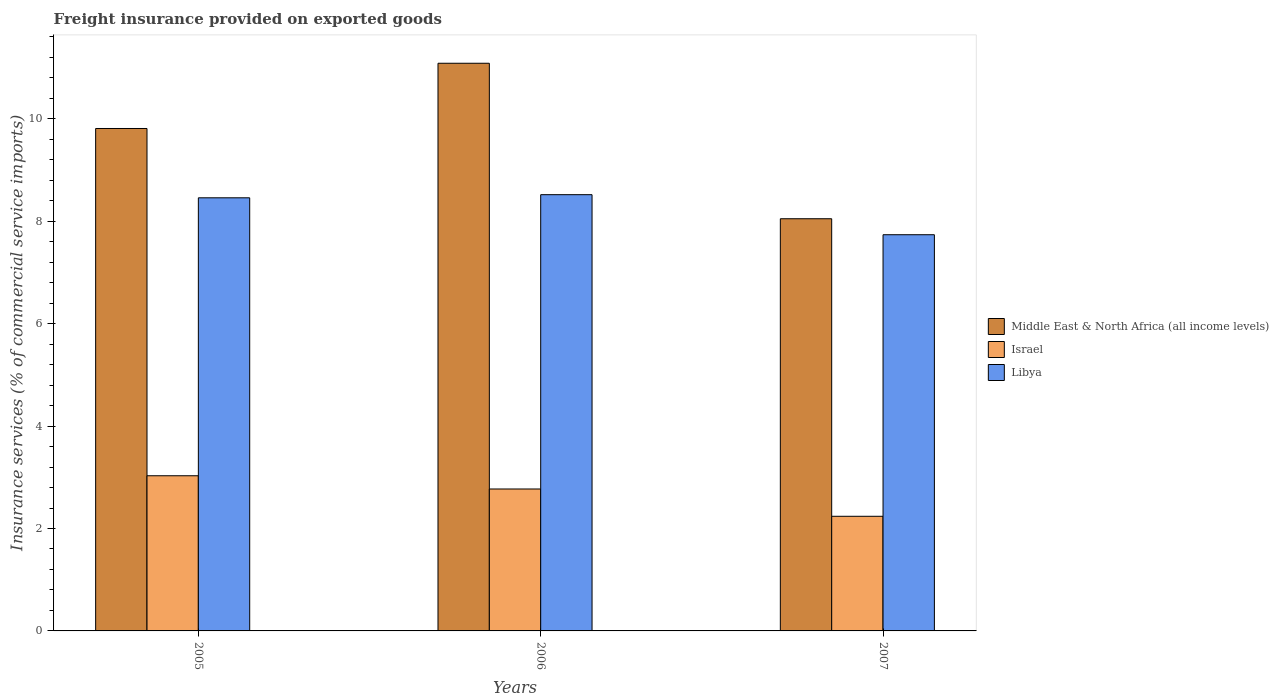How many different coloured bars are there?
Ensure brevity in your answer.  3. Are the number of bars per tick equal to the number of legend labels?
Offer a terse response. Yes. How many bars are there on the 1st tick from the left?
Provide a short and direct response. 3. What is the label of the 1st group of bars from the left?
Keep it short and to the point. 2005. What is the freight insurance provided on exported goods in Middle East & North Africa (all income levels) in 2006?
Your response must be concise. 11.09. Across all years, what is the maximum freight insurance provided on exported goods in Libya?
Offer a very short reply. 8.52. Across all years, what is the minimum freight insurance provided on exported goods in Israel?
Your answer should be compact. 2.24. In which year was the freight insurance provided on exported goods in Israel minimum?
Give a very brief answer. 2007. What is the total freight insurance provided on exported goods in Libya in the graph?
Your answer should be compact. 24.72. What is the difference between the freight insurance provided on exported goods in Libya in 2006 and that in 2007?
Provide a succinct answer. 0.78. What is the difference between the freight insurance provided on exported goods in Israel in 2005 and the freight insurance provided on exported goods in Middle East & North Africa (all income levels) in 2006?
Your response must be concise. -8.06. What is the average freight insurance provided on exported goods in Israel per year?
Your answer should be very brief. 2.68. In the year 2007, what is the difference between the freight insurance provided on exported goods in Libya and freight insurance provided on exported goods in Israel?
Make the answer very short. 5.5. What is the ratio of the freight insurance provided on exported goods in Libya in 2006 to that in 2007?
Provide a short and direct response. 1.1. Is the freight insurance provided on exported goods in Israel in 2006 less than that in 2007?
Keep it short and to the point. No. What is the difference between the highest and the second highest freight insurance provided on exported goods in Middle East & North Africa (all income levels)?
Your response must be concise. 1.27. What is the difference between the highest and the lowest freight insurance provided on exported goods in Middle East & North Africa (all income levels)?
Your answer should be compact. 3.04. In how many years, is the freight insurance provided on exported goods in Middle East & North Africa (all income levels) greater than the average freight insurance provided on exported goods in Middle East & North Africa (all income levels) taken over all years?
Your answer should be compact. 2. Is the sum of the freight insurance provided on exported goods in Libya in 2006 and 2007 greater than the maximum freight insurance provided on exported goods in Middle East & North Africa (all income levels) across all years?
Keep it short and to the point. Yes. What does the 2nd bar from the left in 2005 represents?
Provide a succinct answer. Israel. What does the 3rd bar from the right in 2007 represents?
Your response must be concise. Middle East & North Africa (all income levels). Is it the case that in every year, the sum of the freight insurance provided on exported goods in Libya and freight insurance provided on exported goods in Israel is greater than the freight insurance provided on exported goods in Middle East & North Africa (all income levels)?
Keep it short and to the point. Yes. How many bars are there?
Your answer should be compact. 9. Are all the bars in the graph horizontal?
Give a very brief answer. No. Does the graph contain any zero values?
Provide a short and direct response. No. Does the graph contain grids?
Make the answer very short. No. Where does the legend appear in the graph?
Your answer should be very brief. Center right. How many legend labels are there?
Keep it short and to the point. 3. What is the title of the graph?
Provide a succinct answer. Freight insurance provided on exported goods. Does "Cote d'Ivoire" appear as one of the legend labels in the graph?
Provide a short and direct response. No. What is the label or title of the Y-axis?
Offer a very short reply. Insurance services (% of commercial service imports). What is the Insurance services (% of commercial service imports) of Middle East & North Africa (all income levels) in 2005?
Offer a terse response. 9.81. What is the Insurance services (% of commercial service imports) in Israel in 2005?
Ensure brevity in your answer.  3.03. What is the Insurance services (% of commercial service imports) of Libya in 2005?
Provide a short and direct response. 8.46. What is the Insurance services (% of commercial service imports) in Middle East & North Africa (all income levels) in 2006?
Give a very brief answer. 11.09. What is the Insurance services (% of commercial service imports) of Israel in 2006?
Ensure brevity in your answer.  2.77. What is the Insurance services (% of commercial service imports) of Libya in 2006?
Offer a terse response. 8.52. What is the Insurance services (% of commercial service imports) of Middle East & North Africa (all income levels) in 2007?
Provide a succinct answer. 8.05. What is the Insurance services (% of commercial service imports) of Israel in 2007?
Offer a terse response. 2.24. What is the Insurance services (% of commercial service imports) in Libya in 2007?
Ensure brevity in your answer.  7.74. Across all years, what is the maximum Insurance services (% of commercial service imports) of Middle East & North Africa (all income levels)?
Make the answer very short. 11.09. Across all years, what is the maximum Insurance services (% of commercial service imports) of Israel?
Give a very brief answer. 3.03. Across all years, what is the maximum Insurance services (% of commercial service imports) in Libya?
Ensure brevity in your answer.  8.52. Across all years, what is the minimum Insurance services (% of commercial service imports) in Middle East & North Africa (all income levels)?
Provide a short and direct response. 8.05. Across all years, what is the minimum Insurance services (% of commercial service imports) of Israel?
Your response must be concise. 2.24. Across all years, what is the minimum Insurance services (% of commercial service imports) of Libya?
Make the answer very short. 7.74. What is the total Insurance services (% of commercial service imports) of Middle East & North Africa (all income levels) in the graph?
Your answer should be compact. 28.95. What is the total Insurance services (% of commercial service imports) of Israel in the graph?
Your answer should be compact. 8.04. What is the total Insurance services (% of commercial service imports) in Libya in the graph?
Offer a terse response. 24.72. What is the difference between the Insurance services (% of commercial service imports) of Middle East & North Africa (all income levels) in 2005 and that in 2006?
Your response must be concise. -1.27. What is the difference between the Insurance services (% of commercial service imports) of Israel in 2005 and that in 2006?
Provide a short and direct response. 0.26. What is the difference between the Insurance services (% of commercial service imports) in Libya in 2005 and that in 2006?
Your answer should be very brief. -0.06. What is the difference between the Insurance services (% of commercial service imports) in Middle East & North Africa (all income levels) in 2005 and that in 2007?
Your answer should be very brief. 1.76. What is the difference between the Insurance services (% of commercial service imports) in Israel in 2005 and that in 2007?
Ensure brevity in your answer.  0.79. What is the difference between the Insurance services (% of commercial service imports) in Libya in 2005 and that in 2007?
Offer a very short reply. 0.72. What is the difference between the Insurance services (% of commercial service imports) in Middle East & North Africa (all income levels) in 2006 and that in 2007?
Your response must be concise. 3.04. What is the difference between the Insurance services (% of commercial service imports) of Israel in 2006 and that in 2007?
Offer a very short reply. 0.53. What is the difference between the Insurance services (% of commercial service imports) of Libya in 2006 and that in 2007?
Offer a very short reply. 0.78. What is the difference between the Insurance services (% of commercial service imports) in Middle East & North Africa (all income levels) in 2005 and the Insurance services (% of commercial service imports) in Israel in 2006?
Offer a terse response. 7.04. What is the difference between the Insurance services (% of commercial service imports) of Middle East & North Africa (all income levels) in 2005 and the Insurance services (% of commercial service imports) of Libya in 2006?
Offer a terse response. 1.29. What is the difference between the Insurance services (% of commercial service imports) of Israel in 2005 and the Insurance services (% of commercial service imports) of Libya in 2006?
Your response must be concise. -5.49. What is the difference between the Insurance services (% of commercial service imports) in Middle East & North Africa (all income levels) in 2005 and the Insurance services (% of commercial service imports) in Israel in 2007?
Your answer should be compact. 7.57. What is the difference between the Insurance services (% of commercial service imports) in Middle East & North Africa (all income levels) in 2005 and the Insurance services (% of commercial service imports) in Libya in 2007?
Give a very brief answer. 2.07. What is the difference between the Insurance services (% of commercial service imports) of Israel in 2005 and the Insurance services (% of commercial service imports) of Libya in 2007?
Keep it short and to the point. -4.71. What is the difference between the Insurance services (% of commercial service imports) in Middle East & North Africa (all income levels) in 2006 and the Insurance services (% of commercial service imports) in Israel in 2007?
Offer a very short reply. 8.85. What is the difference between the Insurance services (% of commercial service imports) in Middle East & North Africa (all income levels) in 2006 and the Insurance services (% of commercial service imports) in Libya in 2007?
Provide a short and direct response. 3.35. What is the difference between the Insurance services (% of commercial service imports) of Israel in 2006 and the Insurance services (% of commercial service imports) of Libya in 2007?
Give a very brief answer. -4.97. What is the average Insurance services (% of commercial service imports) of Middle East & North Africa (all income levels) per year?
Give a very brief answer. 9.65. What is the average Insurance services (% of commercial service imports) in Israel per year?
Ensure brevity in your answer.  2.68. What is the average Insurance services (% of commercial service imports) in Libya per year?
Give a very brief answer. 8.24. In the year 2005, what is the difference between the Insurance services (% of commercial service imports) in Middle East & North Africa (all income levels) and Insurance services (% of commercial service imports) in Israel?
Your answer should be compact. 6.78. In the year 2005, what is the difference between the Insurance services (% of commercial service imports) of Middle East & North Africa (all income levels) and Insurance services (% of commercial service imports) of Libya?
Make the answer very short. 1.35. In the year 2005, what is the difference between the Insurance services (% of commercial service imports) in Israel and Insurance services (% of commercial service imports) in Libya?
Provide a succinct answer. -5.43. In the year 2006, what is the difference between the Insurance services (% of commercial service imports) in Middle East & North Africa (all income levels) and Insurance services (% of commercial service imports) in Israel?
Offer a very short reply. 8.31. In the year 2006, what is the difference between the Insurance services (% of commercial service imports) in Middle East & North Africa (all income levels) and Insurance services (% of commercial service imports) in Libya?
Provide a succinct answer. 2.57. In the year 2006, what is the difference between the Insurance services (% of commercial service imports) in Israel and Insurance services (% of commercial service imports) in Libya?
Provide a succinct answer. -5.75. In the year 2007, what is the difference between the Insurance services (% of commercial service imports) in Middle East & North Africa (all income levels) and Insurance services (% of commercial service imports) in Israel?
Your answer should be compact. 5.81. In the year 2007, what is the difference between the Insurance services (% of commercial service imports) of Middle East & North Africa (all income levels) and Insurance services (% of commercial service imports) of Libya?
Offer a terse response. 0.31. In the year 2007, what is the difference between the Insurance services (% of commercial service imports) of Israel and Insurance services (% of commercial service imports) of Libya?
Your answer should be compact. -5.5. What is the ratio of the Insurance services (% of commercial service imports) of Middle East & North Africa (all income levels) in 2005 to that in 2006?
Your answer should be compact. 0.89. What is the ratio of the Insurance services (% of commercial service imports) of Israel in 2005 to that in 2006?
Keep it short and to the point. 1.09. What is the ratio of the Insurance services (% of commercial service imports) in Middle East & North Africa (all income levels) in 2005 to that in 2007?
Make the answer very short. 1.22. What is the ratio of the Insurance services (% of commercial service imports) of Israel in 2005 to that in 2007?
Provide a short and direct response. 1.35. What is the ratio of the Insurance services (% of commercial service imports) in Libya in 2005 to that in 2007?
Offer a very short reply. 1.09. What is the ratio of the Insurance services (% of commercial service imports) of Middle East & North Africa (all income levels) in 2006 to that in 2007?
Provide a succinct answer. 1.38. What is the ratio of the Insurance services (% of commercial service imports) of Israel in 2006 to that in 2007?
Offer a very short reply. 1.24. What is the ratio of the Insurance services (% of commercial service imports) of Libya in 2006 to that in 2007?
Your response must be concise. 1.1. What is the difference between the highest and the second highest Insurance services (% of commercial service imports) of Middle East & North Africa (all income levels)?
Keep it short and to the point. 1.27. What is the difference between the highest and the second highest Insurance services (% of commercial service imports) of Israel?
Offer a very short reply. 0.26. What is the difference between the highest and the second highest Insurance services (% of commercial service imports) of Libya?
Offer a very short reply. 0.06. What is the difference between the highest and the lowest Insurance services (% of commercial service imports) of Middle East & North Africa (all income levels)?
Keep it short and to the point. 3.04. What is the difference between the highest and the lowest Insurance services (% of commercial service imports) of Israel?
Offer a terse response. 0.79. What is the difference between the highest and the lowest Insurance services (% of commercial service imports) in Libya?
Your response must be concise. 0.78. 